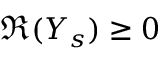<formula> <loc_0><loc_0><loc_500><loc_500>\Re ( Y _ { s } ) \geq 0</formula> 